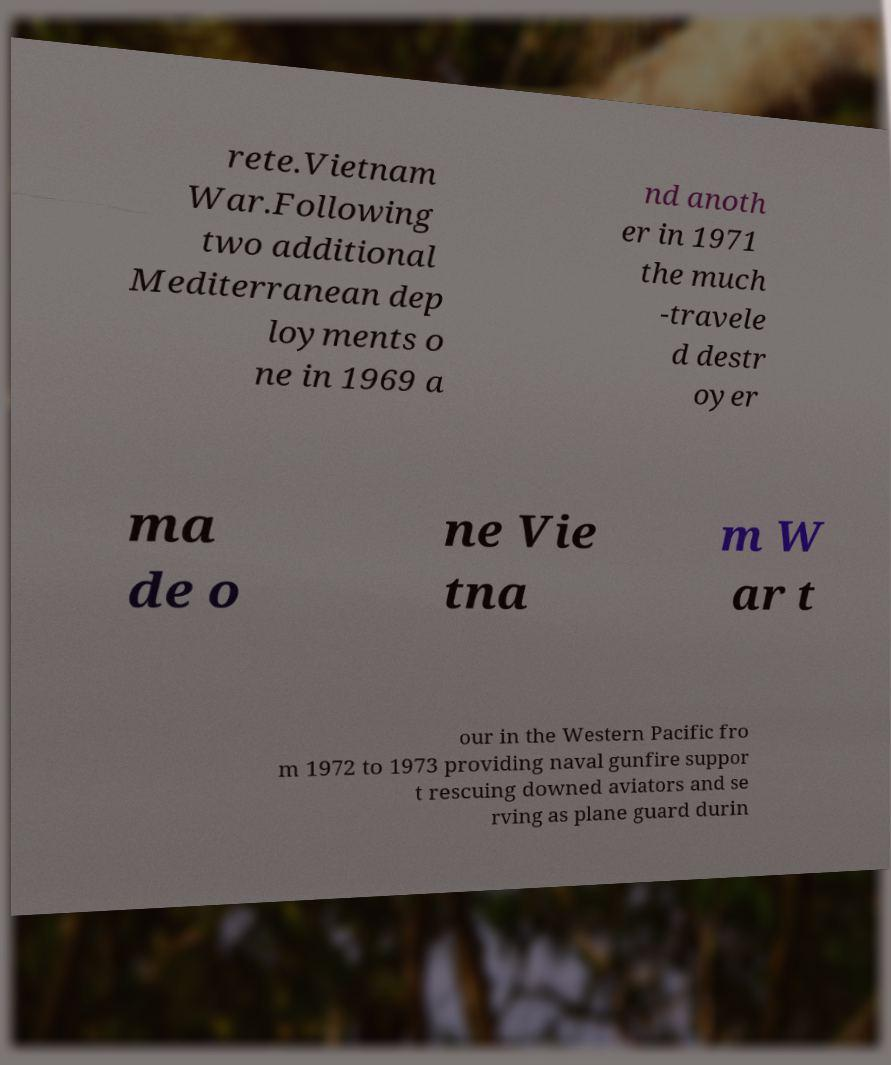Please identify and transcribe the text found in this image. rete.Vietnam War.Following two additional Mediterranean dep loyments o ne in 1969 a nd anoth er in 1971 the much -travele d destr oyer ma de o ne Vie tna m W ar t our in the Western Pacific fro m 1972 to 1973 providing naval gunfire suppor t rescuing downed aviators and se rving as plane guard durin 